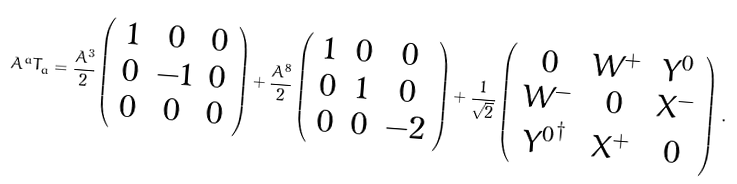<formula> <loc_0><loc_0><loc_500><loc_500>A ^ { a } T _ { a } = \frac { A ^ { 3 } } { 2 } \left ( \begin{array} { c c c } 1 & 0 & 0 \\ 0 & - 1 & 0 \\ 0 & 0 & 0 \end{array} \right ) + \frac { A ^ { 8 } } { 2 } \left ( \begin{array} { c c c } 1 & 0 & 0 \\ 0 & 1 & 0 \\ 0 & 0 & - 2 \end{array} \right ) + \frac { 1 } { \sqrt { 2 } } \left ( \begin{array} { c c c } 0 & W ^ { + } & Y ^ { 0 } \\ W ^ { - } & 0 & X ^ { - } \\ { Y ^ { 0 } } ^ { \dagger } & X ^ { + } & 0 \end{array} \right ) \, .</formula> 